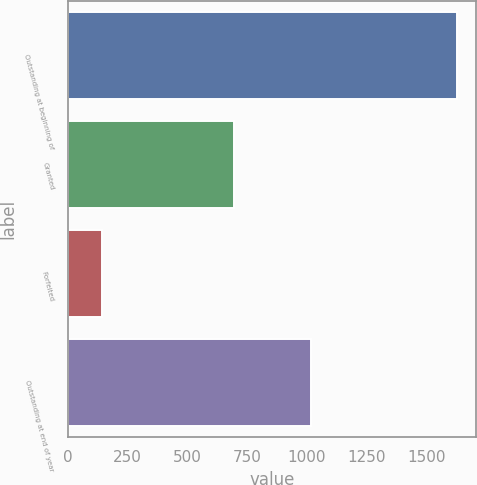<chart> <loc_0><loc_0><loc_500><loc_500><bar_chart><fcel>Outstanding at beginning of<fcel>Granted<fcel>Forfeited<fcel>Outstanding at end of year<nl><fcel>1627<fcel>695<fcel>144<fcel>1019<nl></chart> 